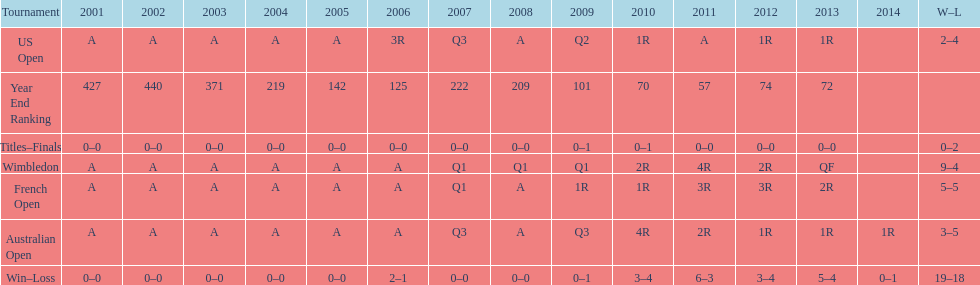What was the total number of matches played from 2001 to 2014? 37. 